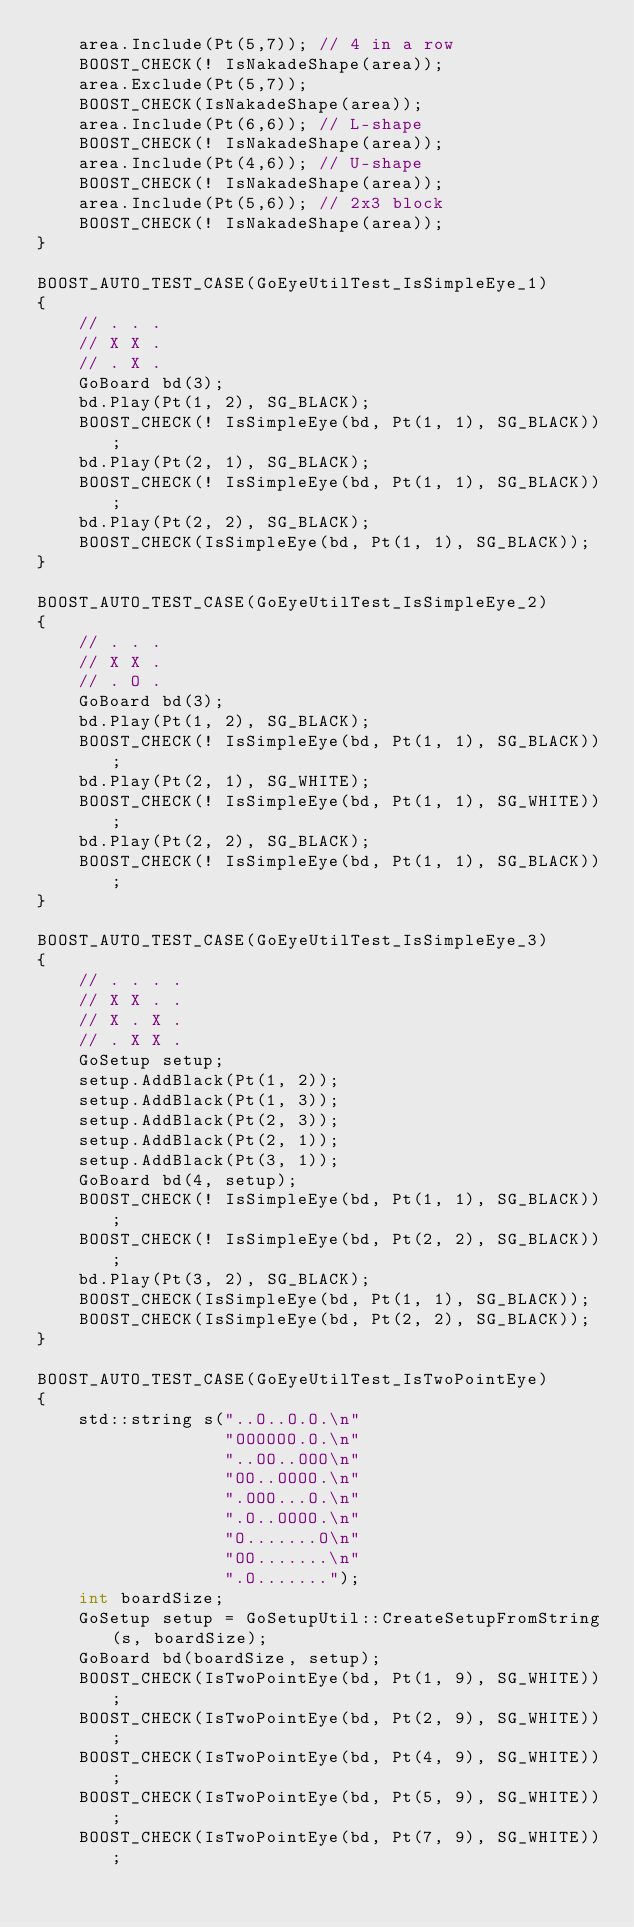<code> <loc_0><loc_0><loc_500><loc_500><_C++_>    area.Include(Pt(5,7)); // 4 in a row
    BOOST_CHECK(! IsNakadeShape(area));
    area.Exclude(Pt(5,7));
    BOOST_CHECK(IsNakadeShape(area));
    area.Include(Pt(6,6)); // L-shape
    BOOST_CHECK(! IsNakadeShape(area));
    area.Include(Pt(4,6)); // U-shape
    BOOST_CHECK(! IsNakadeShape(area));
    area.Include(Pt(5,6)); // 2x3 block
    BOOST_CHECK(! IsNakadeShape(area));
}

BOOST_AUTO_TEST_CASE(GoEyeUtilTest_IsSimpleEye_1)
{
    // . . .
    // X X .
    // . X .
    GoBoard bd(3);
    bd.Play(Pt(1, 2), SG_BLACK);
    BOOST_CHECK(! IsSimpleEye(bd, Pt(1, 1), SG_BLACK));
    bd.Play(Pt(2, 1), SG_BLACK);
    BOOST_CHECK(! IsSimpleEye(bd, Pt(1, 1), SG_BLACK));
    bd.Play(Pt(2, 2), SG_BLACK);
    BOOST_CHECK(IsSimpleEye(bd, Pt(1, 1), SG_BLACK));
}

BOOST_AUTO_TEST_CASE(GoEyeUtilTest_IsSimpleEye_2)
{
    // . . .
    // X X .
    // . O .
    GoBoard bd(3);
    bd.Play(Pt(1, 2), SG_BLACK);
    BOOST_CHECK(! IsSimpleEye(bd, Pt(1, 1), SG_BLACK));
    bd.Play(Pt(2, 1), SG_WHITE);
    BOOST_CHECK(! IsSimpleEye(bd, Pt(1, 1), SG_WHITE));
    bd.Play(Pt(2, 2), SG_BLACK);
    BOOST_CHECK(! IsSimpleEye(bd, Pt(1, 1), SG_BLACK));
}

BOOST_AUTO_TEST_CASE(GoEyeUtilTest_IsSimpleEye_3)
{
    // . . . .
    // X X . .
    // X . X .
    // . X X .
    GoSetup setup;
    setup.AddBlack(Pt(1, 2));
    setup.AddBlack(Pt(1, 3));
    setup.AddBlack(Pt(2, 3));
    setup.AddBlack(Pt(2, 1));
    setup.AddBlack(Pt(3, 1));
    GoBoard bd(4, setup);
    BOOST_CHECK(! IsSimpleEye(bd, Pt(1, 1), SG_BLACK));
    BOOST_CHECK(! IsSimpleEye(bd, Pt(2, 2), SG_BLACK));
    bd.Play(Pt(3, 2), SG_BLACK);
    BOOST_CHECK(IsSimpleEye(bd, Pt(1, 1), SG_BLACK));
    BOOST_CHECK(IsSimpleEye(bd, Pt(2, 2), SG_BLACK));
}

BOOST_AUTO_TEST_CASE(GoEyeUtilTest_IsTwoPointEye)
{
    std::string s("..O..O.O.\n"
                  "OOOOOO.O.\n"
                  "..OO..OOO\n"
                  "OO..OOOO.\n"
                  ".OOO...O.\n"
                  ".O..OOOO.\n"
                  "O.......O\n"
                  "OO.......\n"
                  ".O.......");
    int boardSize;
    GoSetup setup = GoSetupUtil::CreateSetupFromString(s, boardSize);
    GoBoard bd(boardSize, setup);
    BOOST_CHECK(IsTwoPointEye(bd, Pt(1, 9), SG_WHITE));
    BOOST_CHECK(IsTwoPointEye(bd, Pt(2, 9), SG_WHITE));
    BOOST_CHECK(IsTwoPointEye(bd, Pt(4, 9), SG_WHITE));
    BOOST_CHECK(IsTwoPointEye(bd, Pt(5, 9), SG_WHITE));
    BOOST_CHECK(IsTwoPointEye(bd, Pt(7, 9), SG_WHITE));</code> 